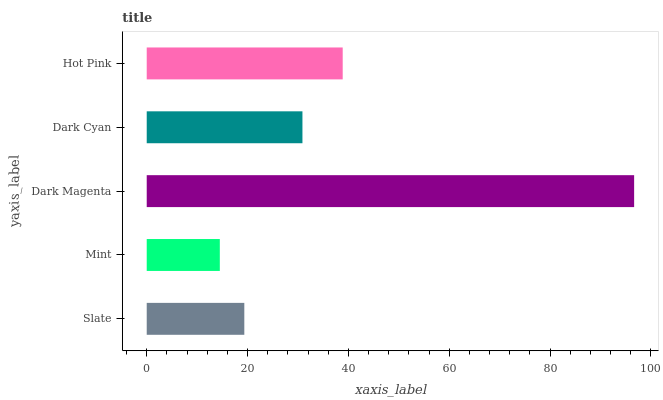Is Mint the minimum?
Answer yes or no. Yes. Is Dark Magenta the maximum?
Answer yes or no. Yes. Is Dark Magenta the minimum?
Answer yes or no. No. Is Mint the maximum?
Answer yes or no. No. Is Dark Magenta greater than Mint?
Answer yes or no. Yes. Is Mint less than Dark Magenta?
Answer yes or no. Yes. Is Mint greater than Dark Magenta?
Answer yes or no. No. Is Dark Magenta less than Mint?
Answer yes or no. No. Is Dark Cyan the high median?
Answer yes or no. Yes. Is Dark Cyan the low median?
Answer yes or no. Yes. Is Slate the high median?
Answer yes or no. No. Is Slate the low median?
Answer yes or no. No. 